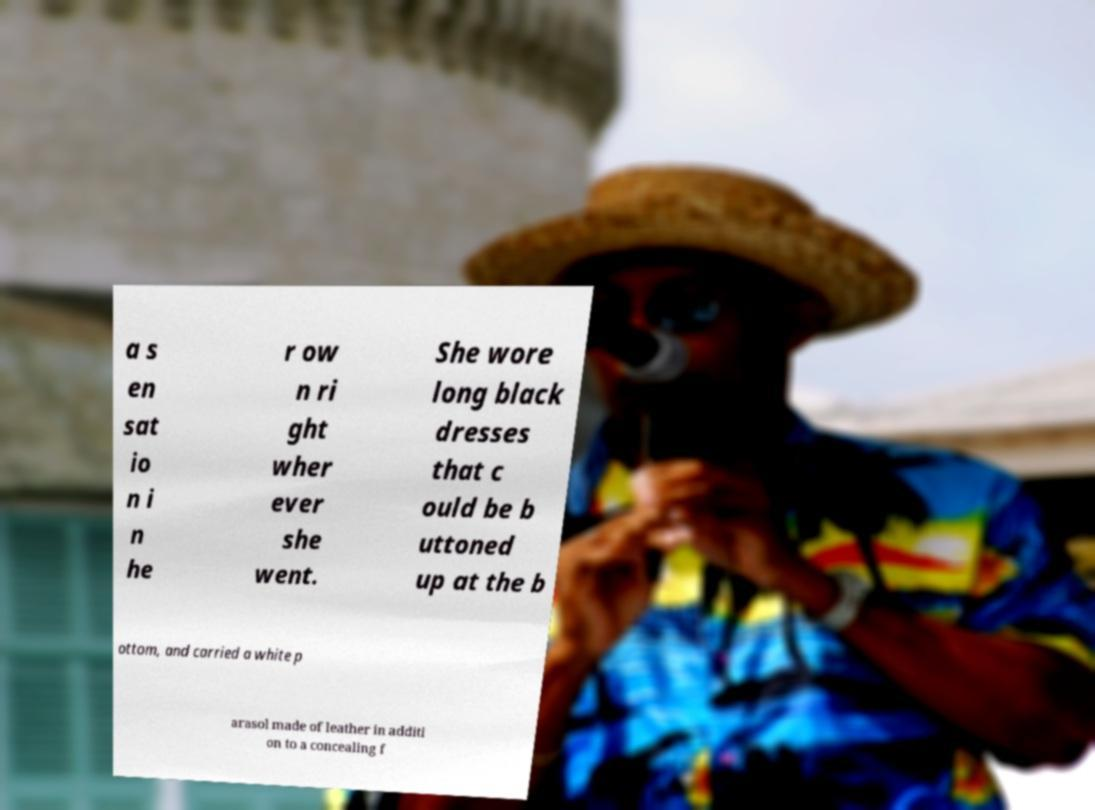Please read and relay the text visible in this image. What does it say? a s en sat io n i n he r ow n ri ght wher ever she went. She wore long black dresses that c ould be b uttoned up at the b ottom, and carried a white p arasol made of leather in additi on to a concealing f 